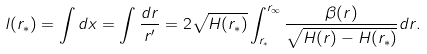<formula> <loc_0><loc_0><loc_500><loc_500>l ( r _ { * } ) = \int d x = \int \frac { d r } { r ^ { \prime } } = 2 \sqrt { H ( r _ { * } ) } \int _ { r _ { * } } ^ { r _ { \infty } } \frac { \beta ( r ) } { \sqrt { H ( r ) - H ( r _ { * } ) } } d r .</formula> 